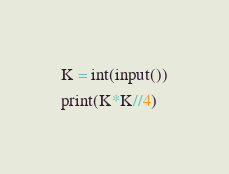Convert code to text. <code><loc_0><loc_0><loc_500><loc_500><_Python_>K = int(input())
print(K*K//4)
</code> 